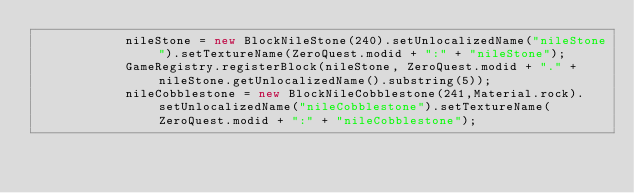Convert code to text. <code><loc_0><loc_0><loc_500><loc_500><_Java_>	    	nileStone = new BlockNileStone(240).setUnlocalizedName("nileStone").setTextureName(ZeroQuest.modid + ":" + "nileStone");
	    	GameRegistry.registerBlock(nileStone, ZeroQuest.modid + "." + nileStone.getUnlocalizedName().substring(5));
	    	nileCobblestone = new BlockNileCobblestone(241,Material.rock).setUnlocalizedName("nileCobblestone").setTextureName(ZeroQuest.modid + ":" + "nileCobblestone");</code> 